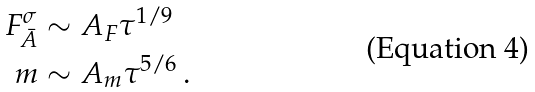<formula> <loc_0><loc_0><loc_500><loc_500>F ^ { \sigma } _ { \bar { A } } & \sim A _ { F } \tau ^ { 1 / 9 } \\ m & \sim A _ { m } \tau ^ { 5 / 6 } \, .</formula> 